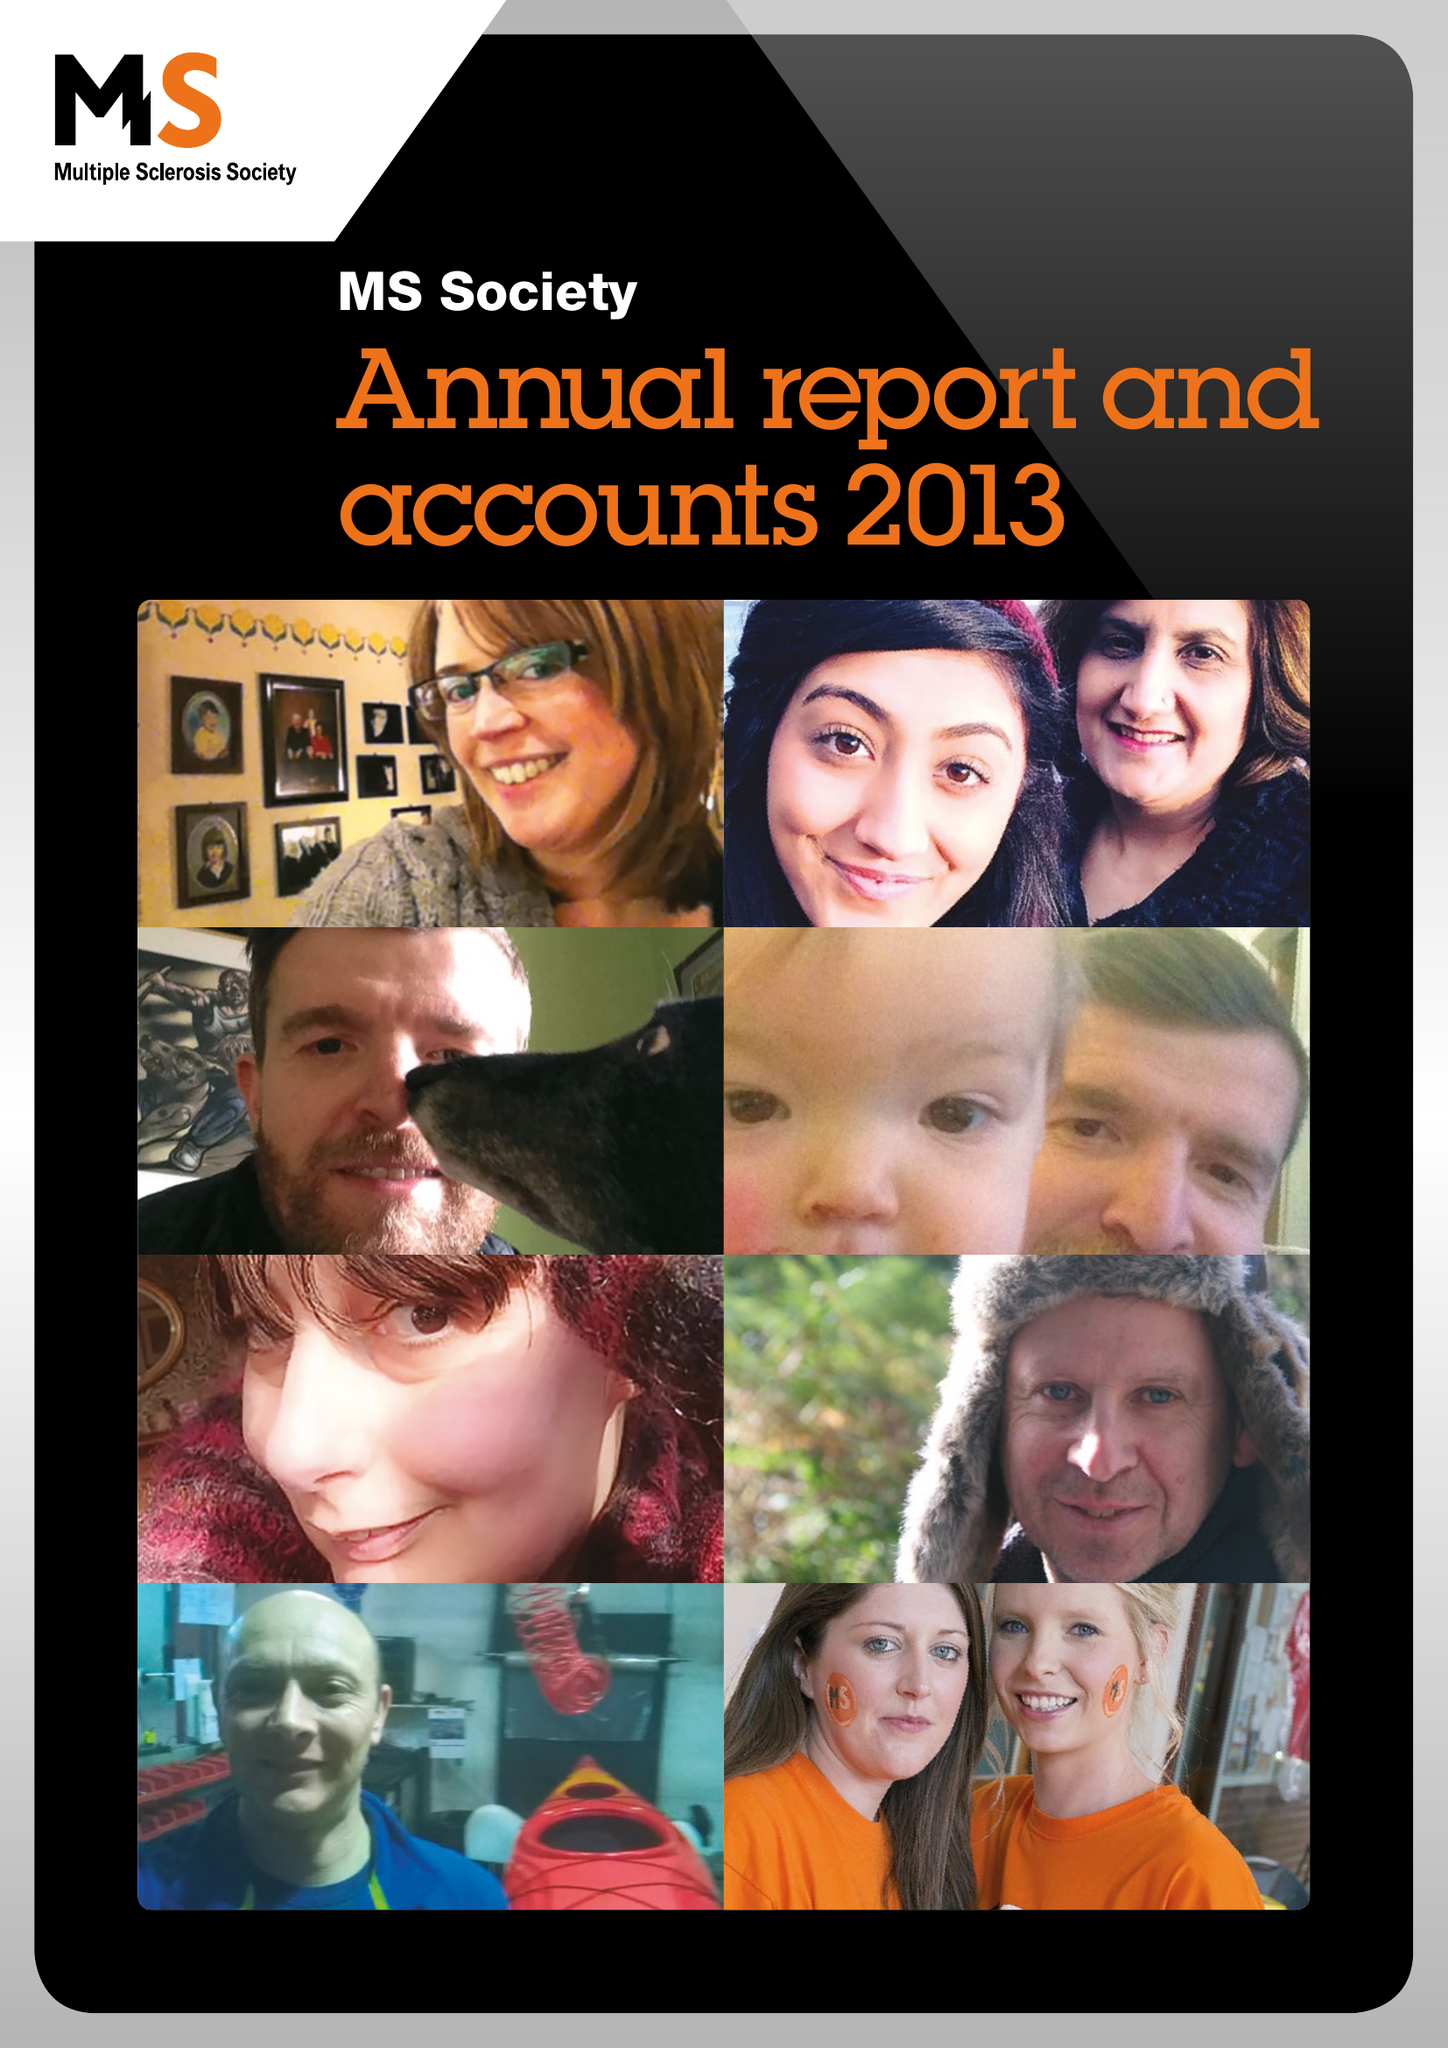What is the value for the spending_annually_in_british_pounds?
Answer the question using a single word or phrase. 28036000.00 